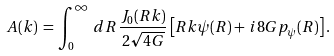<formula> <loc_0><loc_0><loc_500><loc_500>A ( k ) \, = \, \int _ { 0 } ^ { \infty } \, d R \, \frac { J _ { 0 } ( R k ) } { 2 \sqrt { 4 G } } \left [ R k \psi ( R ) + \, i 8 G p _ { \psi } ( R ) \right ] .</formula> 